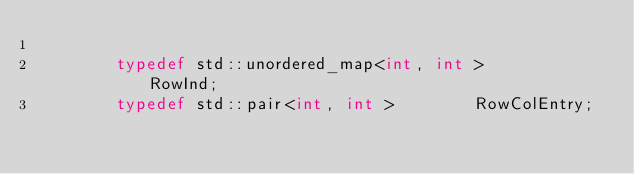Convert code to text. <code><loc_0><loc_0><loc_500><loc_500><_C++_>
        typedef std::unordered_map<int, int >         RowInd;
        typedef std::pair<int, int >        RowColEntry;</code> 